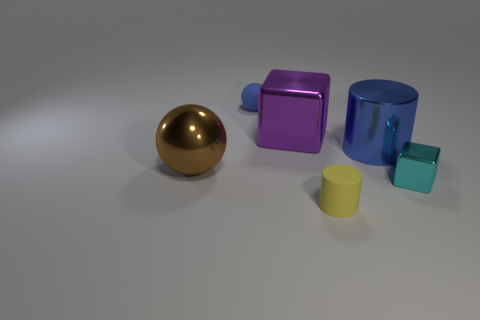Add 4 big cyan rubber cylinders. How many objects exist? 10 Subtract all spheres. How many objects are left? 4 Add 6 tiny matte cylinders. How many tiny matte cylinders exist? 7 Subtract 0 gray cubes. How many objects are left? 6 Subtract all tiny blue metal cylinders. Subtract all blue things. How many objects are left? 4 Add 5 big purple shiny blocks. How many big purple shiny blocks are left? 6 